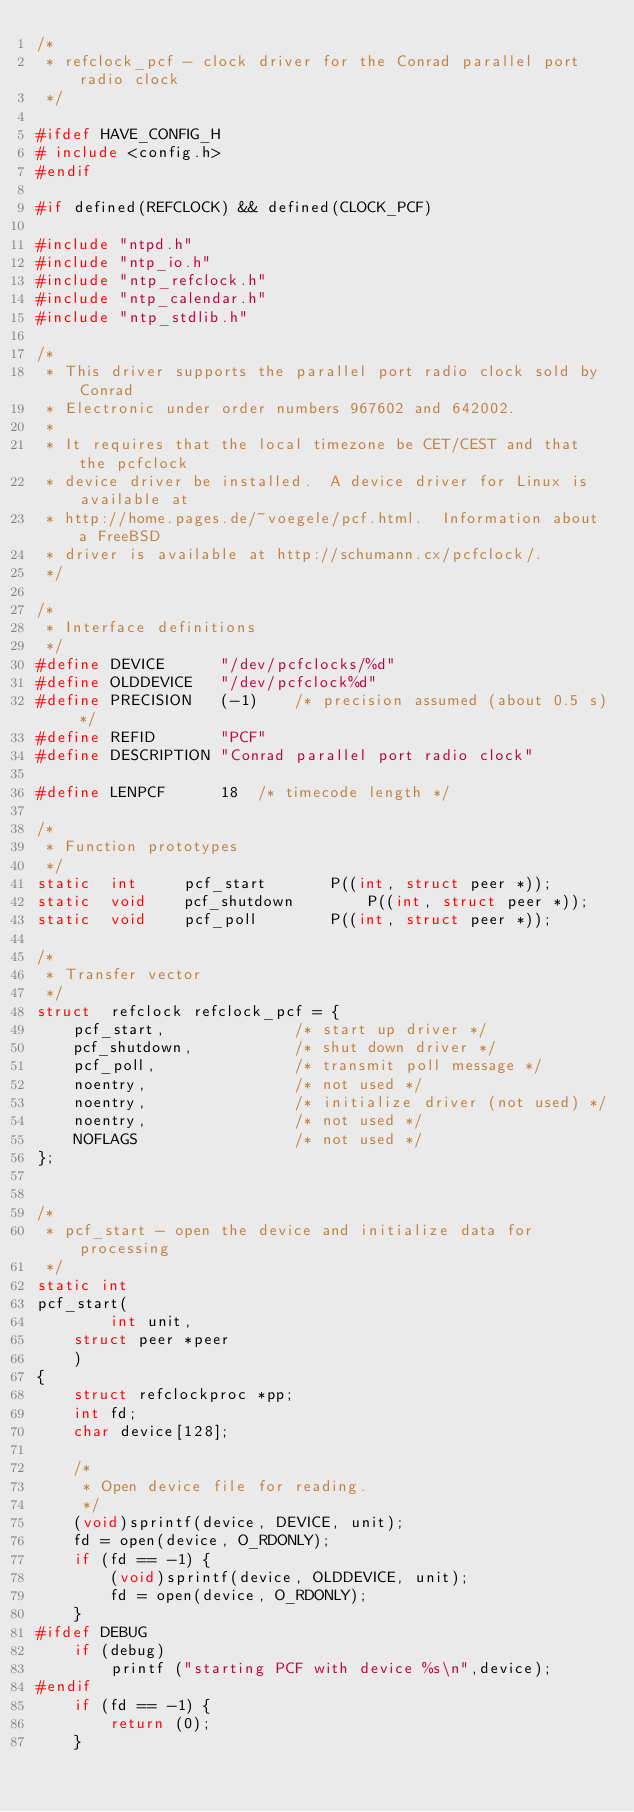<code> <loc_0><loc_0><loc_500><loc_500><_C_>/*
 * refclock_pcf - clock driver for the Conrad parallel port radio clock
 */

#ifdef HAVE_CONFIG_H
# include <config.h>
#endif

#if defined(REFCLOCK) && defined(CLOCK_PCF)

#include "ntpd.h"
#include "ntp_io.h"
#include "ntp_refclock.h"
#include "ntp_calendar.h"
#include "ntp_stdlib.h"

/*
 * This driver supports the parallel port radio clock sold by Conrad
 * Electronic under order numbers 967602 and 642002.
 *
 * It requires that the local timezone be CET/CEST and that the pcfclock
 * device driver be installed.  A device driver for Linux is available at
 * http://home.pages.de/~voegele/pcf.html.  Information about a FreeBSD
 * driver is available at http://schumann.cx/pcfclock/.
 */

/*
 * Interface definitions
 */
#define	DEVICE		"/dev/pcfclocks/%d"
#define	OLDDEVICE	"/dev/pcfclock%d"
#define	PRECISION	(-1)	/* precision assumed (about 0.5 s) */
#define REFID		"PCF"
#define DESCRIPTION	"Conrad parallel port radio clock"

#define LENPCF		18	/* timecode length */

/*
 * Function prototypes
 */
static	int 	pcf_start 		P((int, struct peer *));
static	void	pcf_shutdown		P((int, struct peer *));
static	void	pcf_poll		P((int, struct peer *));

/*
 * Transfer vector
 */
struct  refclock refclock_pcf = {
	pcf_start,              /* start up driver */
	pcf_shutdown,           /* shut down driver */
	pcf_poll,               /* transmit poll message */
	noentry,                /* not used */
	noentry,                /* initialize driver (not used) */
	noentry,                /* not used */
	NOFLAGS                 /* not used */
};


/*
 * pcf_start - open the device and initialize data for processing
 */
static int
pcf_start(
     	int unit,
	struct peer *peer
	)
{
	struct refclockproc *pp;
	int fd;
	char device[128];

	/*
	 * Open device file for reading.
	 */
	(void)sprintf(device, DEVICE, unit);
	fd = open(device, O_RDONLY);
	if (fd == -1) {
		(void)sprintf(device, OLDDEVICE, unit);
		fd = open(device, O_RDONLY);
	}
#ifdef DEBUG
	if (debug)
		printf ("starting PCF with device %s\n",device);
#endif
	if (fd == -1) {
		return (0);
	}
	</code> 